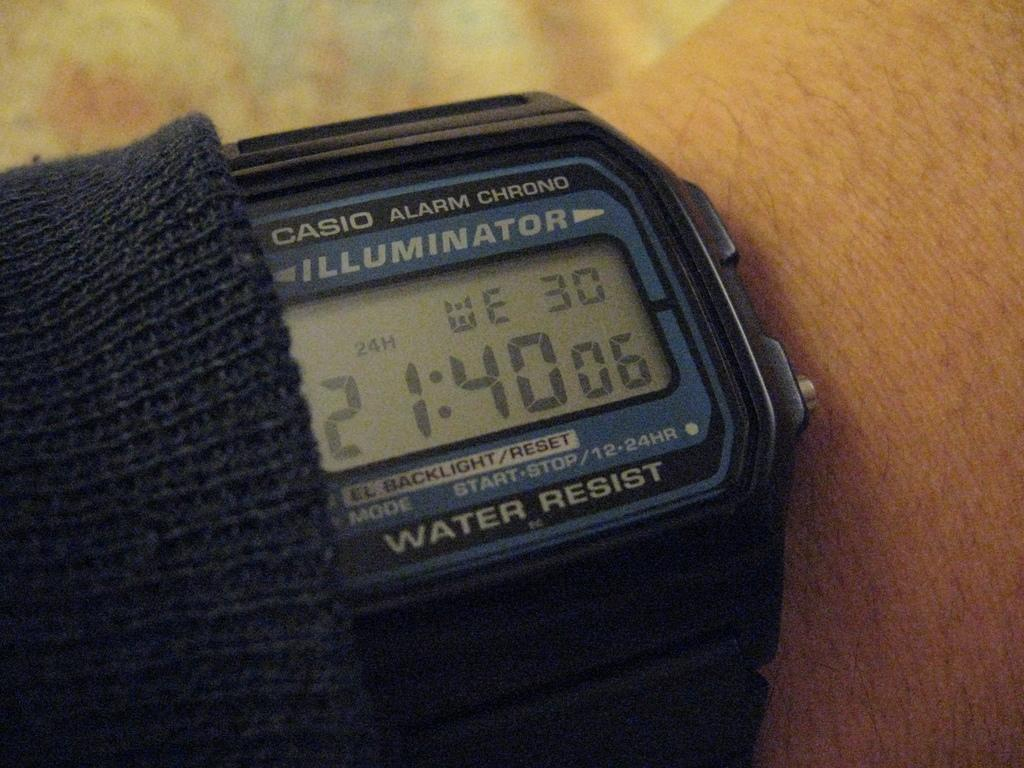<image>
Provide a brief description of the given image. The Casio watch reads a time of 21:40. 